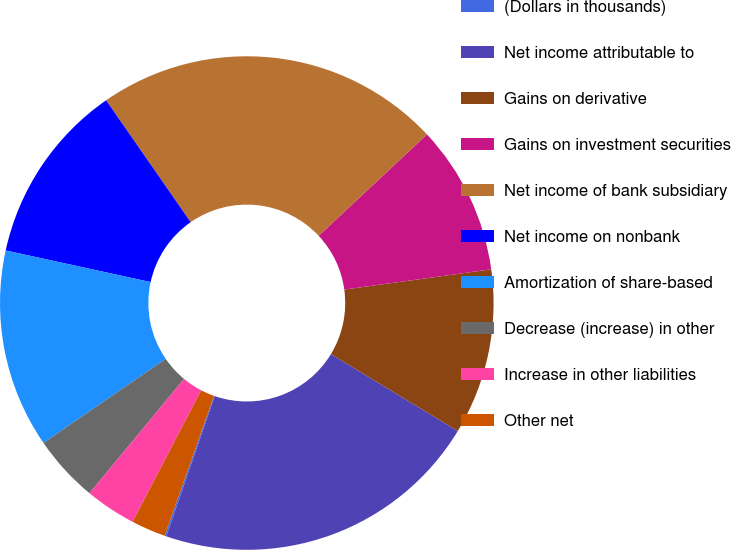Convert chart to OTSL. <chart><loc_0><loc_0><loc_500><loc_500><pie_chart><fcel>(Dollars in thousands)<fcel>Net income attributable to<fcel>Gains on derivative<fcel>Gains on investment securities<fcel>Net income of bank subsidiary<fcel>Net income on nonbank<fcel>Amortization of share-based<fcel>Decrease (increase) in other<fcel>Increase in other liabilities<fcel>Other net<nl><fcel>0.11%<fcel>21.61%<fcel>10.86%<fcel>9.79%<fcel>22.68%<fcel>11.93%<fcel>13.01%<fcel>4.41%<fcel>3.34%<fcel>2.26%<nl></chart> 